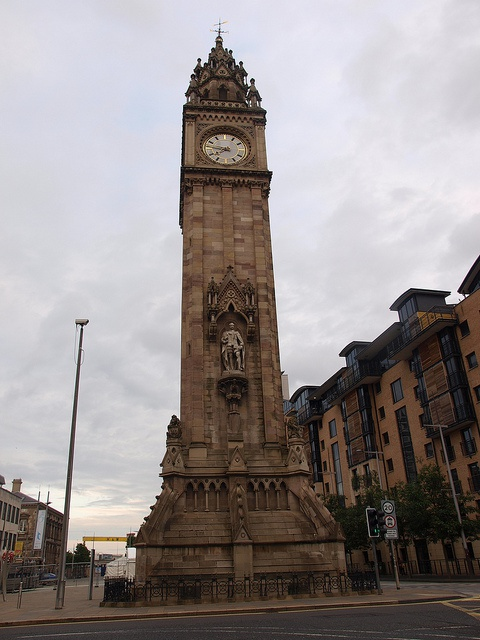Describe the objects in this image and their specific colors. I can see clock in lightgray, darkgray, tan, black, and gray tones and traffic light in lightgray, black, and gray tones in this image. 